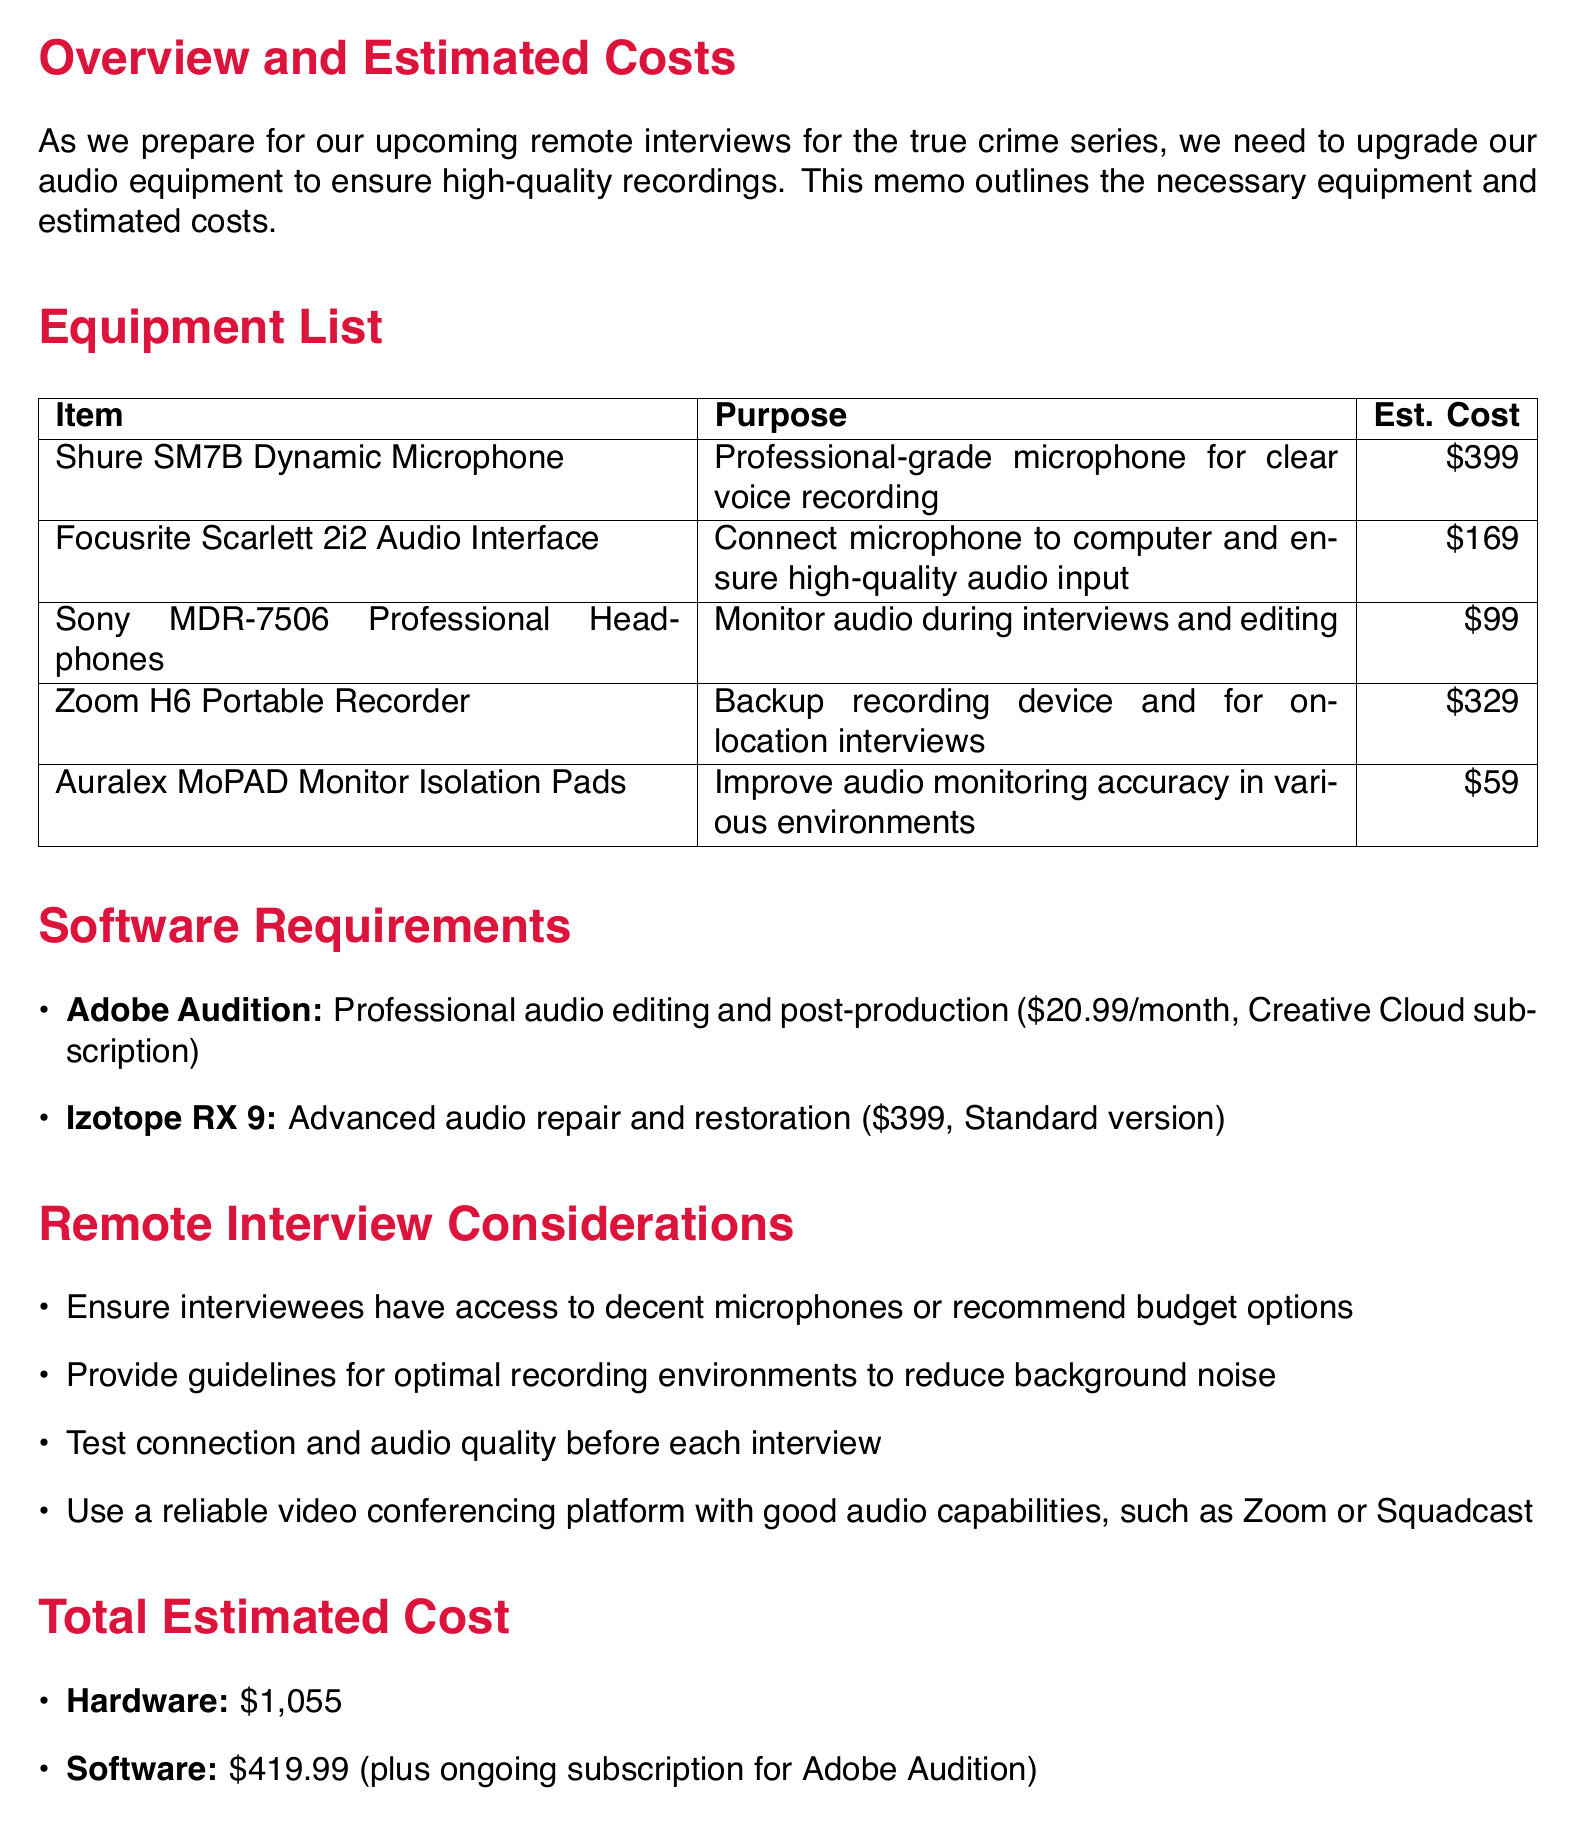What is the title of the memo? The title of the memo is specified at the top of the document.
Answer: New Audio Equipment for Remote Interviews - Overview and Costs What is the estimated cost of the Shure SM7B Dynamic Microphone? The estimated cost is provided in the equipment list section of the document.
Answer: $399 What software is used for professional audio editing? The document lists specific software requirements for audio editing and post-production.
Answer: Adobe Audition What is the total estimated cost for hardware? The total estimated cost for hardware is mentioned in the total estimated cost section.
Answer: $1,055 Which headphones are recommended for monitoring audio? The equipment list provides the name of the headphones suitable for monitoring audio.
Answer: Sony MDR-7506 Professional Headphones How much does the Adobe Audition subscription cost monthly? The monthly cost of Adobe Audition is specified in the software requirements section.
Answer: $20.99/month What is one consideration for remote interviews? The document outlines specific considerations for conducting remote interviews.
Answer: Ensure interviewees have access to decent microphones or recommend budget options What is the purpose of the Zoom H6 Portable Recorder? The purpose is detailed in the equipment list.
Answer: Backup recording device and for on-location interviews 